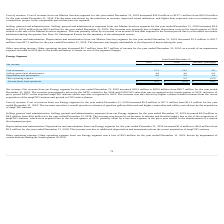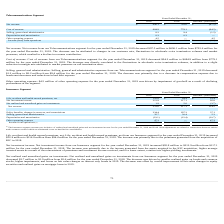According to Hc2 Holdings's financial document, What was the net revenue for the year ended December 31, 2019? According to the financial document, $696.1 million. The relevant text states: "ended December 31, 2019 decreased $97.5 million to $696.1 million from $793.6 million for the year ended December 31, 2018. The decrease can be attributed to changes..." Also, What was the selling, general and administrative expense for the year ended December 31, 2019? According to the financial document, $8.2 million. The relevant text states: "ended December 31, 2019 decreased $1.2 million to $8.2 million from $9.4 million for the year ended December 31, 2018. The decrease was primarily due to a decrease..." Also, What was the cost of revenue for the year ended December 31, 2019? According to the financial document, $684.9 million. The relevant text states: "ended December 31, 2019 decreased $94.2 million to $684.9 million from $779.1 million for the year ended December 31, 2018. The decrease was directly correlated to th..." Also, can you calculate: What was the percentage change in the net revenue from 2018 to 2019? To answer this question, I need to perform calculations using the financial data. The calculation is: 696.1 / 793.6 - 1, which equals -12.29 (percentage). This is based on the information: "Net revenue $ 696.1 $ 793.6 $ (97.5) Net revenue $ 696.1 $ 793.6 $ (97.5)..." The key data points involved are: 696.1, 793.6. Also, can you calculate: What was the average cost of revenue for 2018 and 2019? To answer this question, I need to perform calculations using the financial data. The calculation is: (684.9 + 779.1) / 2, which equals 732 (in millions). This is based on the information: "Cost of revenue 684.9 779.1 (94.2) Cost of revenue 684.9 779.1 (94.2)..." The key data points involved are: 684.9, 779.1. Also, can you calculate: What is the percentage change in the Depreciation and amortization from 2018 to 2019? I cannot find a specific answer to this question in the financial document. 